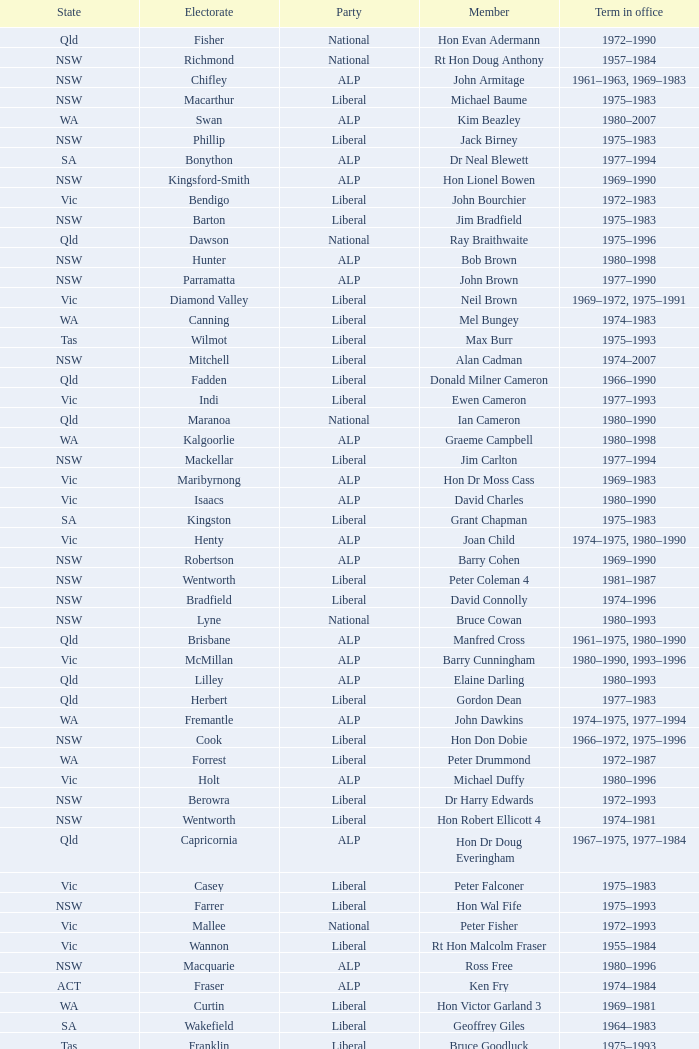Which party had a member from the state of Vic and an Electorate called Wannon? Liberal. Could you help me parse every detail presented in this table? {'header': ['State', 'Electorate', 'Party', 'Member', 'Term in office'], 'rows': [['Qld', 'Fisher', 'National', 'Hon Evan Adermann', '1972–1990'], ['NSW', 'Richmond', 'National', 'Rt Hon Doug Anthony', '1957–1984'], ['NSW', 'Chifley', 'ALP', 'John Armitage', '1961–1963, 1969–1983'], ['NSW', 'Macarthur', 'Liberal', 'Michael Baume', '1975–1983'], ['WA', 'Swan', 'ALP', 'Kim Beazley', '1980–2007'], ['NSW', 'Phillip', 'Liberal', 'Jack Birney', '1975–1983'], ['SA', 'Bonython', 'ALP', 'Dr Neal Blewett', '1977–1994'], ['NSW', 'Kingsford-Smith', 'ALP', 'Hon Lionel Bowen', '1969–1990'], ['Vic', 'Bendigo', 'Liberal', 'John Bourchier', '1972–1983'], ['NSW', 'Barton', 'Liberal', 'Jim Bradfield', '1975–1983'], ['Qld', 'Dawson', 'National', 'Ray Braithwaite', '1975–1996'], ['NSW', 'Hunter', 'ALP', 'Bob Brown', '1980–1998'], ['NSW', 'Parramatta', 'ALP', 'John Brown', '1977–1990'], ['Vic', 'Diamond Valley', 'Liberal', 'Neil Brown', '1969–1972, 1975–1991'], ['WA', 'Canning', 'Liberal', 'Mel Bungey', '1974–1983'], ['Tas', 'Wilmot', 'Liberal', 'Max Burr', '1975–1993'], ['NSW', 'Mitchell', 'Liberal', 'Alan Cadman', '1974–2007'], ['Qld', 'Fadden', 'Liberal', 'Donald Milner Cameron', '1966–1990'], ['Vic', 'Indi', 'Liberal', 'Ewen Cameron', '1977–1993'], ['Qld', 'Maranoa', 'National', 'Ian Cameron', '1980–1990'], ['WA', 'Kalgoorlie', 'ALP', 'Graeme Campbell', '1980–1998'], ['NSW', 'Mackellar', 'Liberal', 'Jim Carlton', '1977–1994'], ['Vic', 'Maribyrnong', 'ALP', 'Hon Dr Moss Cass', '1969–1983'], ['Vic', 'Isaacs', 'ALP', 'David Charles', '1980–1990'], ['SA', 'Kingston', 'Liberal', 'Grant Chapman', '1975–1983'], ['Vic', 'Henty', 'ALP', 'Joan Child', '1974–1975, 1980–1990'], ['NSW', 'Robertson', 'ALP', 'Barry Cohen', '1969–1990'], ['NSW', 'Wentworth', 'Liberal', 'Peter Coleman 4', '1981–1987'], ['NSW', 'Bradfield', 'Liberal', 'David Connolly', '1974–1996'], ['NSW', 'Lyne', 'National', 'Bruce Cowan', '1980–1993'], ['Qld', 'Brisbane', 'ALP', 'Manfred Cross', '1961–1975, 1980–1990'], ['Vic', 'McMillan', 'ALP', 'Barry Cunningham', '1980–1990, 1993–1996'], ['Qld', 'Lilley', 'ALP', 'Elaine Darling', '1980–1993'], ['Qld', 'Herbert', 'Liberal', 'Gordon Dean', '1977–1983'], ['WA', 'Fremantle', 'ALP', 'John Dawkins', '1974–1975, 1977–1994'], ['NSW', 'Cook', 'Liberal', 'Hon Don Dobie', '1966–1972, 1975–1996'], ['WA', 'Forrest', 'Liberal', 'Peter Drummond', '1972–1987'], ['Vic', 'Holt', 'ALP', 'Michael Duffy', '1980–1996'], ['NSW', 'Berowra', 'Liberal', 'Dr Harry Edwards', '1972–1993'], ['NSW', 'Wentworth', 'Liberal', 'Hon Robert Ellicott 4', '1974–1981'], ['Qld', 'Capricornia', 'ALP', 'Hon Dr Doug Everingham', '1967–1975, 1977–1984'], ['Vic', 'Casey', 'Liberal', 'Peter Falconer', '1975–1983'], ['NSW', 'Farrer', 'Liberal', 'Hon Wal Fife', '1975–1993'], ['Vic', 'Mallee', 'National', 'Peter Fisher', '1972–1993'], ['Vic', 'Wannon', 'Liberal', 'Rt Hon Malcolm Fraser', '1955–1984'], ['NSW', 'Macquarie', 'ALP', 'Ross Free', '1980–1996'], ['ACT', 'Fraser', 'ALP', 'Ken Fry', '1974–1984'], ['WA', 'Curtin', 'Liberal', 'Hon Victor Garland 3', '1969–1981'], ['SA', 'Wakefield', 'Liberal', 'Geoffrey Giles', '1964–1983'], ['Tas', 'Franklin', 'Liberal', 'Bruce Goodluck', '1975–1993'], ['Tas', 'Braddon', 'Liberal', 'Hon Ray Groom', '1975–1984'], ['SA', 'Boothby', 'Liberal', 'Steele Hall 2', '1981–1996'], ['Vic', 'Chisholm', 'Liberal', 'Graham Harris', '1980–1983'], ['Vic', 'Wills', 'ALP', 'Bob Hawke', '1980–1992'], ['Qld', 'Oxley', 'ALP', 'Hon Bill Hayden', '1961–1988'], ['NSW', 'Riverina', 'National', 'Noel Hicks', '1980–1998'], ['Qld', 'Petrie', 'Liberal', 'John Hodges', '1974–1983, 1984–1987'], ['Tas', 'Denison', 'Liberal', 'Michael Hodgman', '1975–1987'], ['Vic', 'Melbourne Ports', 'ALP', 'Clyde Holding', '1977–1998'], ['NSW', 'Bennelong', 'Liberal', 'Hon John Howard', '1974–2007'], ['Vic', 'Batman', 'ALP', 'Brian Howe', '1977–1996'], ['Qld', 'Griffith', 'ALP', 'Ben Humphreys', '1977–1996'], ['NSW', 'Gwydir', 'National', 'Hon Ralph Hunt', '1969–1989'], ['SA', 'Adelaide', 'ALP', 'Chris Hurford', '1969–1988'], ['WA', 'Moore', 'Liberal', 'John Hyde', '1974–1983'], ['Vic', 'Melbourne', 'ALP', 'Ted Innes', '1972–1983'], ['SA', 'Hawker', 'ALP', 'Ralph Jacobi', '1969–1987'], ['Vic', 'Deakin', 'Liberal', 'Alan Jarman', '1966–1983'], ['Vic', 'Scullin', 'ALP', 'Dr Harry Jenkins', '1969–1985'], ['NSW', 'Hughes', 'ALP', 'Hon Les Johnson', '1955–1966, 1969–1984'], ['Vic', 'Lalor', 'ALP', 'Barry Jones', '1977–1998'], ['NSW', 'Newcastle', 'ALP', 'Hon Charles Jones', '1958–1983'], ['Qld', 'Bowman', 'Liberal', 'David Jull', '1975–1983, 1984–2007'], ['Qld', 'Kennedy', 'National', 'Hon Bob Katter', '1966–1990'], ['NSW', 'Blaxland', 'ALP', 'Hon Paul Keating', '1969–1996'], ['ACT', 'Canberra', 'ALP', 'Ros Kelly', '1980–1995'], ['Vic', 'Hotham', 'ALP', 'Lewis Kent', '1980–1990'], ['NSW', 'Werriwa', 'ALP', 'John Kerin', '1972–1975, 1978–1994'], ['Qld', 'Moreton', 'Liberal', 'Hon Jim Killen', '1955–1983'], ['NSW', 'Prospect', 'ALP', 'Dr Dick Klugman', '1969–1990'], ['Vic', 'Murray', 'National', 'Bruce Lloyd', '1971–1996'], ['NSW', 'Hume', 'National', 'Stephen Lusher', '1974–1984'], ['Vic', 'Flinders', 'Liberal', 'Rt Hon Phillip Lynch 6', '1966–1982'], ['NSW', 'Warringah', 'Liberal', 'Hon Michael MacKellar', '1969–1994'], ['NSW', 'Calare', 'National', 'Sandy Mackenzie', '1975–1983'], ['Vic', 'Balaclava', 'Liberal', 'Hon Ian Macphee', '1974–1990'], ['NSW', 'Lowe', 'ALP', 'Michael Maher 5', '1982–1987'], ['WA', 'Perth', 'Liberal', 'Ross McLean', '1975–1983'], ['SA', 'Boothby', 'Liberal', 'Hon John McLeay 2', '1966–1981'], ['NSW', 'Grayndler', 'ALP', 'Leo McLeay', '1979–2004'], ['NSW', 'Sydney', 'ALP', 'Leslie McMahon', '1975–1983'], ['NSW', 'Lowe', 'Liberal', 'Rt Hon Sir William McMahon 5', '1949–1981'], ['Qld', 'Darling Downs', 'National', 'Tom McVeigh', '1972–1988'], ['Vic', 'Ballarat', 'ALP', 'John Mildren', '1980–1990'], ['Qld', 'Wide Bay', 'National', 'Clarrie Millar', '1974–1990'], ['Vic', 'La Trobe', 'ALP', 'Peter Milton', '1980–1990'], ['Qld', 'Ryan', 'Liberal', 'John Moore', '1975–2001'], ['NSW', 'Shortland', 'ALP', 'Peter Morris', '1972–1998'], ['NSW', 'St George', 'ALP', 'Hon Bill Morrison', '1969–1975, 1980–1984'], ['NSW', 'Banks', 'ALP', 'John Mountford', '1980–1990'], ['Tas', 'Bass', 'Liberal', 'Hon Kevin Newman', '1975–1984'], ['Vic', 'Gippsland', 'National', 'Hon Peter Nixon', '1961–1983'], ['NSW', 'Paterson', 'National', "Frank O'Keefe", '1969–1984'], ['Vic', 'Kooyong', 'Liberal', 'Hon Andrew Peacock', '1966–1994'], ['SA', 'Barker', 'Liberal', 'James Porter', '1975–1990'], ['Vic', 'Flinders', 'Liberal', 'Peter Reith 6', '1982–1983, 1984–2001'], ['Qld', 'McPherson', 'Liberal', 'Hon Eric Robinson 1', '1972–1990'], ['NSW', 'Cowper', 'National', 'Hon Ian Robinson', '1963–1981'], ['WA', 'Curtin', 'Liberal', 'Allan Rocher 3', '1981–1998'], ['NSW', 'Dundas', 'Liberal', 'Philip Ruddock', '1973–present'], ['NSW', 'Eden-Monaro', 'Liberal', 'Murray Sainsbury', '1975–1983'], ['Vic', 'Corio', 'ALP', 'Hon Gordon Scholes', '1967–1993'], ['SA', 'Hindmarsh', 'ALP', 'John Scott', '1980–1993'], ['WA', 'Tangney', 'Liberal', 'Peter Shack', '1977–1983, 1984–1993'], ['Vic', 'Higgins', 'Liberal', 'Roger Shipton', '1975–1990'], ['NSW', 'New England', 'National', 'Rt Hon Ian Sinclair', '1963–1998'], ['Vic', 'Bruce', 'Liberal', 'Rt Hon Sir Billy Snedden', '1955–1983'], ['NSW', 'North Sydney', 'Liberal', 'John Spender', '1980–1990'], ['Vic', 'Corangamite', 'Liberal', 'Hon Tony Street', '1966–1984'], ['NT', 'Northern Territory', 'CLP', 'Grant Tambling', '1980–1983'], ['Vic', 'Burke', 'ALP', 'Dr Andrew Theophanous', '1980–2001'], ['Qld', 'Leichhardt', 'National', 'Hon David Thomson', '1975–1983'], ['WA', "O'Connor", 'Liberal', 'Wilson Tuckey', '1980–2010'], ['NSW', 'Reid', 'ALP', 'Hon Tom Uren', '1958–1990'], ['WA', 'Stirling', 'Liberal', 'Hon Ian Viner', '1972–1983'], ['SA', 'Grey', 'ALP', 'Laurie Wallis', '1969–1983'], ['NSW', 'Cunningham', 'ALP', 'Stewart West', '1977–1993'], ['Qld', 'McPherson', 'Liberal', 'Peter White 1', '1981–1990'], ['Vic', 'Gellibrand', 'ALP', 'Ralph Willis', '1972–1998'], ['SA', 'Sturt', 'Liberal', 'Ian Wilson', '1966–1969, 1972–1993'], ['SA', 'Port Adelaide', 'ALP', 'Mick Young', '1974–1988']]} 